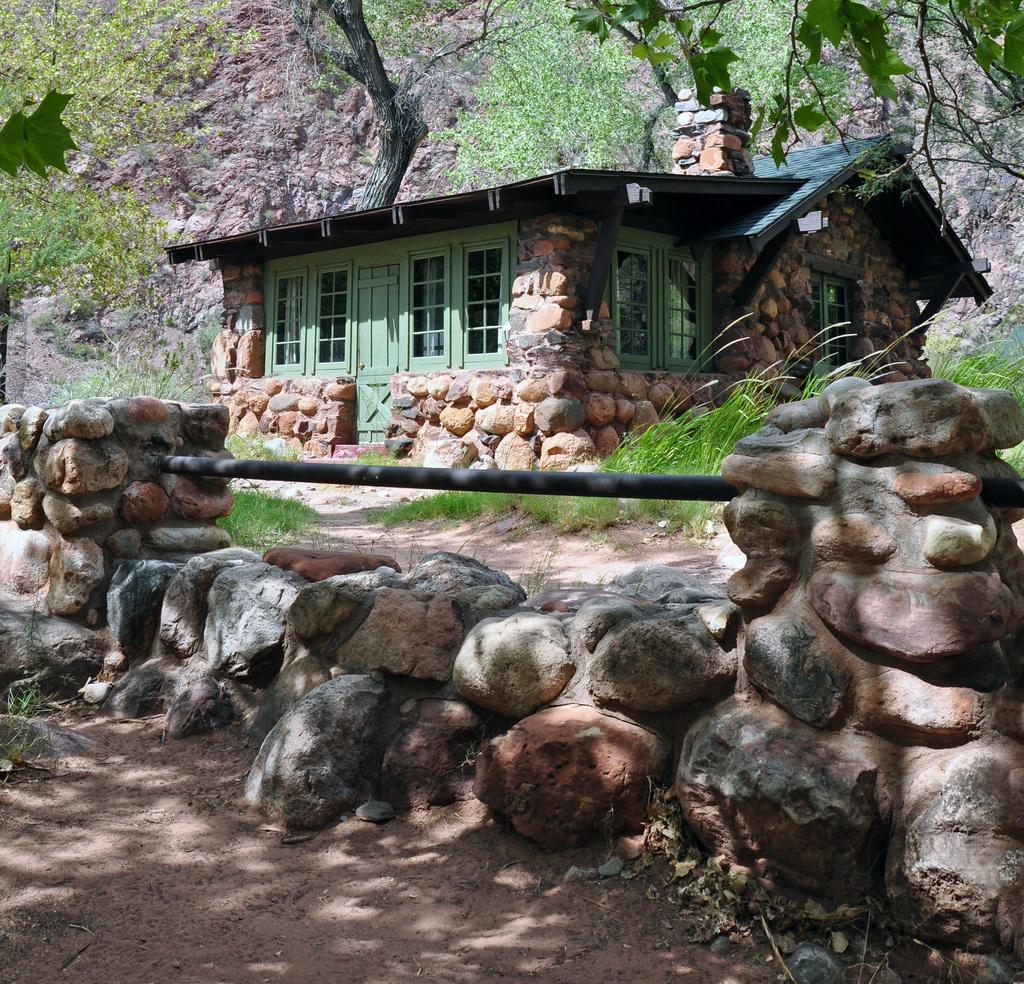How would you summarize this image in a sentence or two? In this picture, we can see a stone wall attached with a pole, ground, plants, grass, trees, and we can see house built with stones, we can see door, windows, roof and chimney of the house, and we can see the rock in the background. 